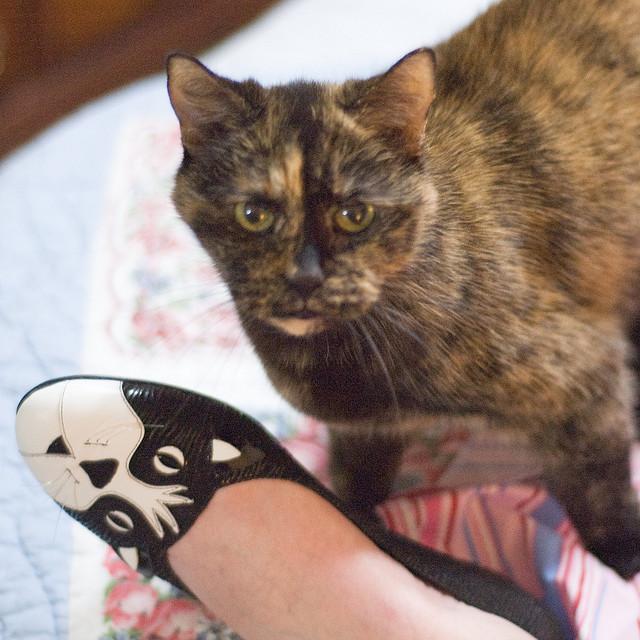What's are the colors is the cat?
Give a very brief answer. Brown and black. What is the main color of the cat?
Concise answer only. Brown. What direction is the cat gazing?
Be succinct. Forward. Does this cat have beautiful eyes?
Concise answer only. Yes. Does this tortoiseshell cat think the slipper is another cat?
Be succinct. No. Is this cat cute?
Write a very short answer. Yes. What kind of shoe is the woman wearing?
Short answer required. Cat. 